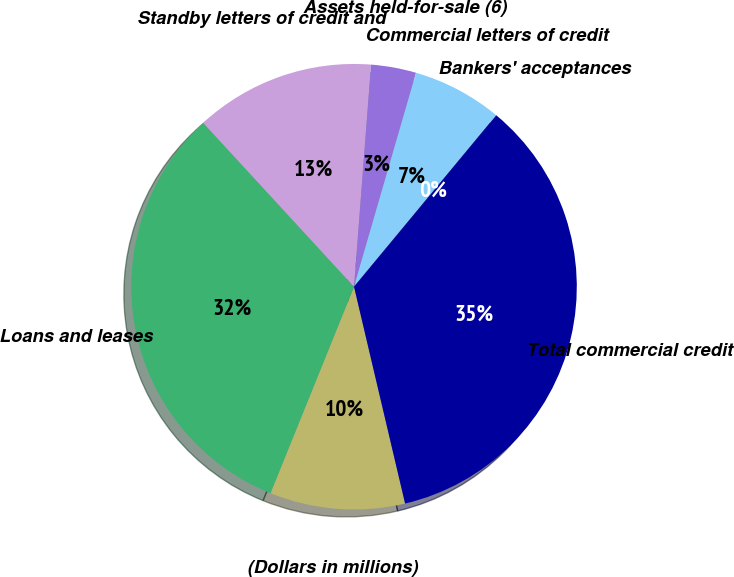<chart> <loc_0><loc_0><loc_500><loc_500><pie_chart><fcel>(Dollars in millions)<fcel>Loans and leases<fcel>Standby letters of credit and<fcel>Assets held-for-sale (6)<fcel>Commercial letters of credit<fcel>Bankers' acceptances<fcel>Total commercial credit<nl><fcel>9.8%<fcel>32.04%<fcel>13.06%<fcel>3.27%<fcel>6.53%<fcel>0.0%<fcel>35.3%<nl></chart> 